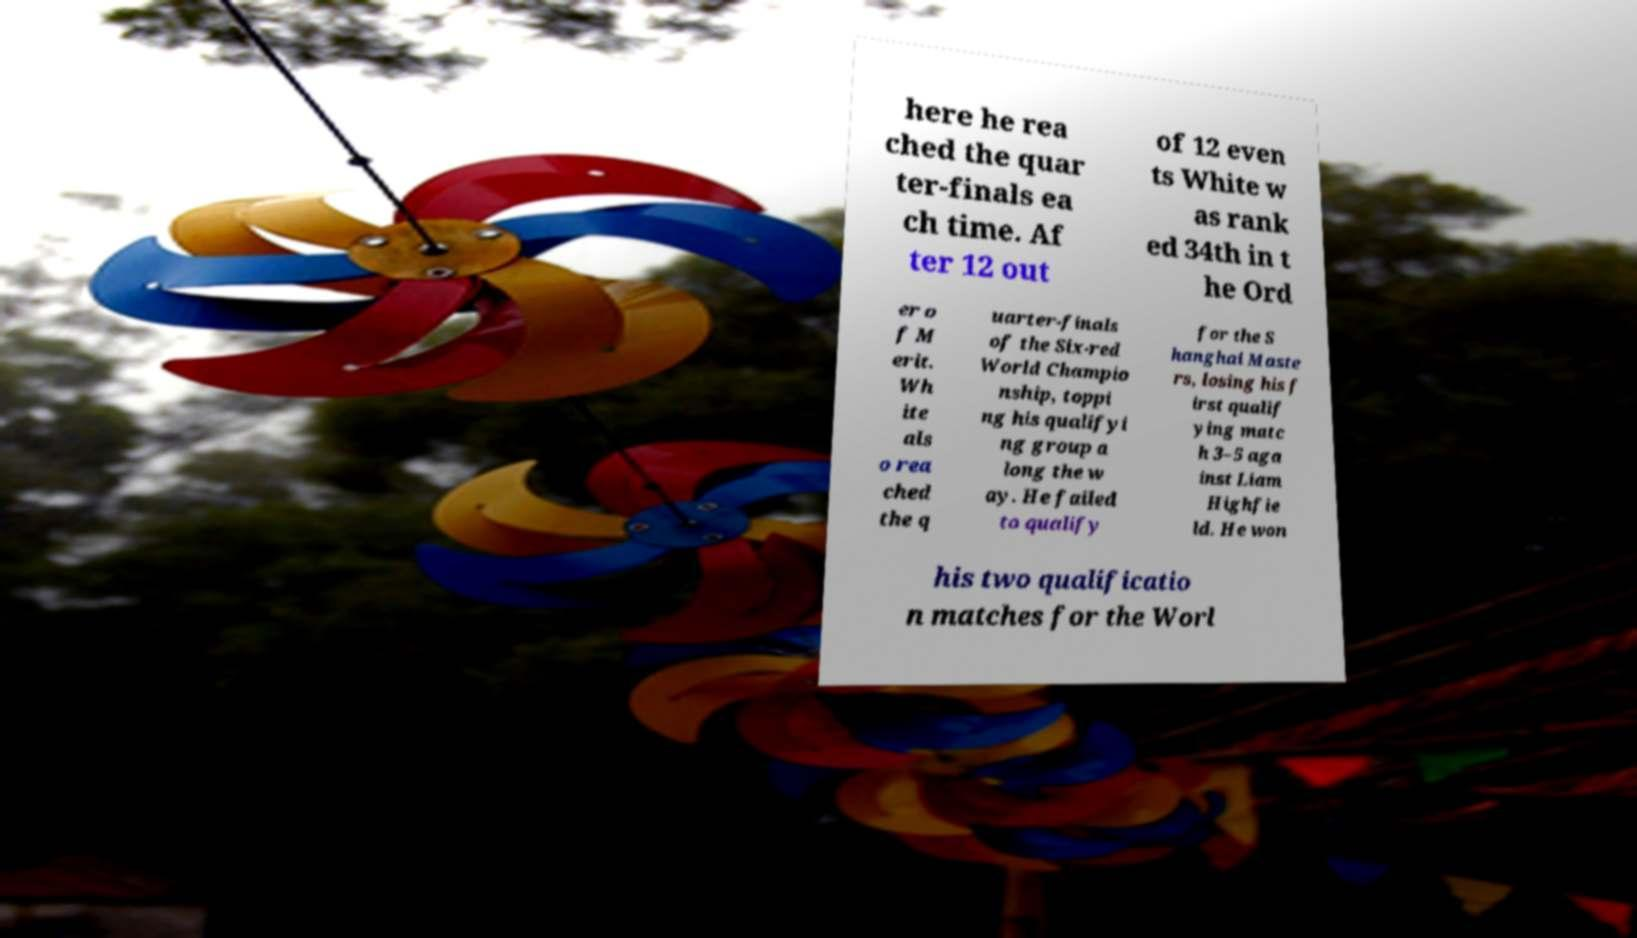There's text embedded in this image that I need extracted. Can you transcribe it verbatim? here he rea ched the quar ter-finals ea ch time. Af ter 12 out of 12 even ts White w as rank ed 34th in t he Ord er o f M erit. Wh ite als o rea ched the q uarter-finals of the Six-red World Champio nship, toppi ng his qualifyi ng group a long the w ay. He failed to qualify for the S hanghai Maste rs, losing his f irst qualif ying matc h 3–5 aga inst Liam Highfie ld. He won his two qualificatio n matches for the Worl 